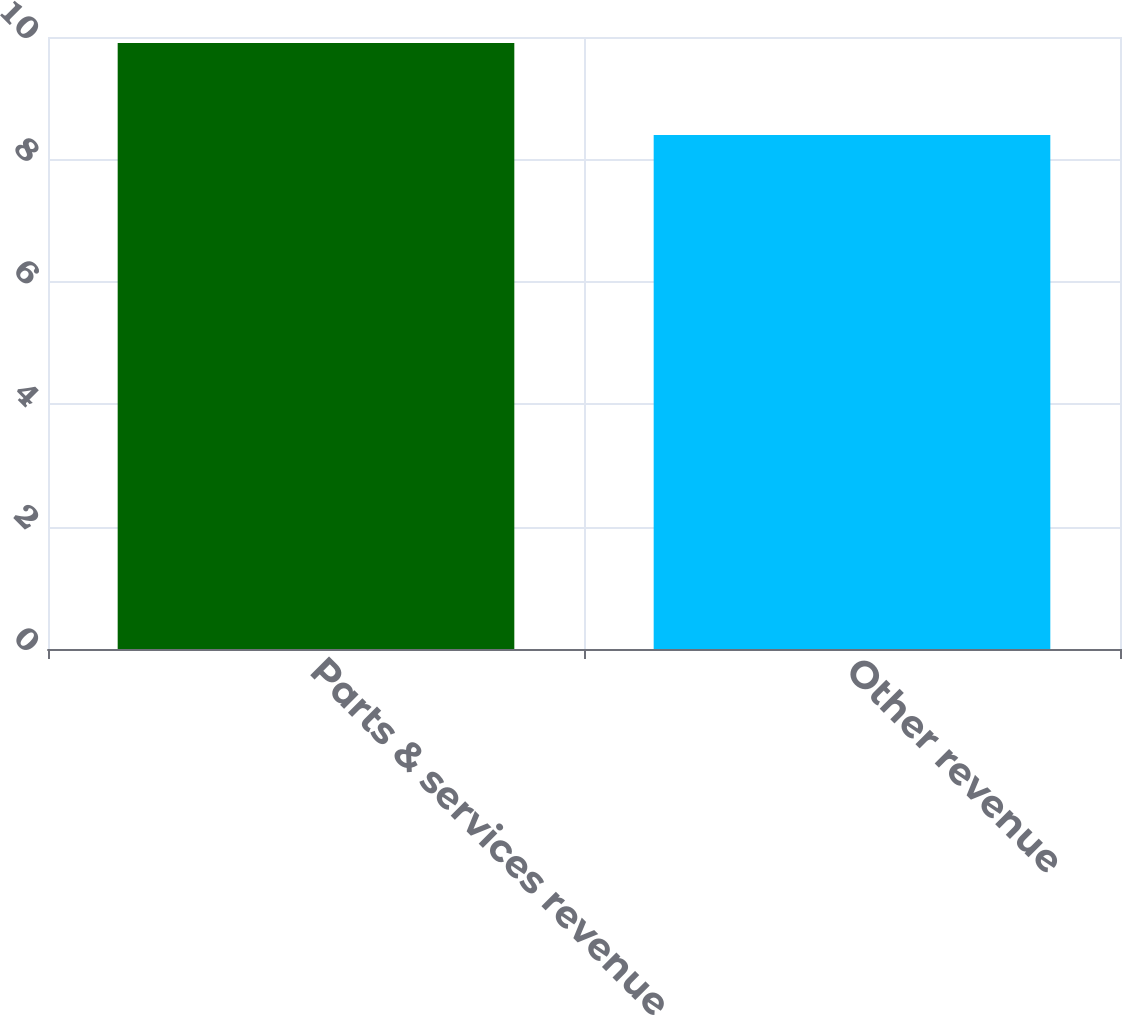Convert chart. <chart><loc_0><loc_0><loc_500><loc_500><bar_chart><fcel>Parts & services revenue<fcel>Other revenue<nl><fcel>9.9<fcel>8.4<nl></chart> 